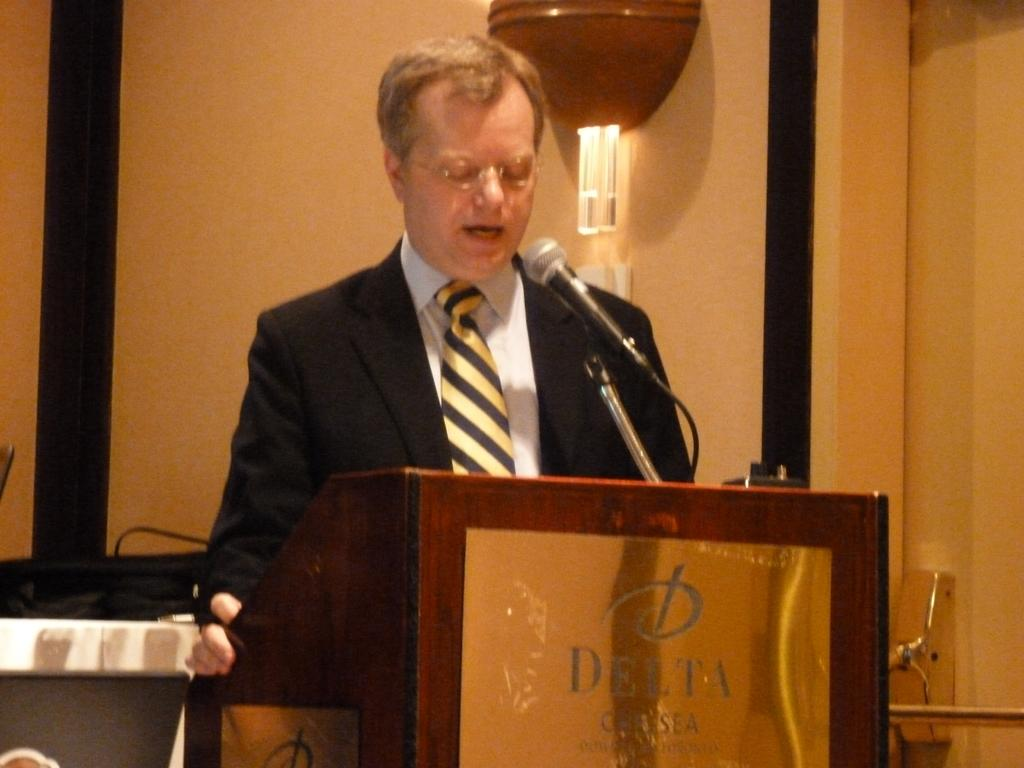What is the main subject of the image? The main subject of the image is a man standing. Can you describe the man's appearance? The man is wearing clothes and spectacles. What objects are present in the image related to a possible event or presentation? There is a podium, a microphone, and cable wires in the image. Is there any source of illumination in the image? Yes, there is a light in the image. How many knees does the man have in the image? The number of knees cannot be determined from the image, as only the man's upper body is visible. What is the man's afterthought about the event in the image? There is no information about the man's thoughts or afterthoughts in the image. 